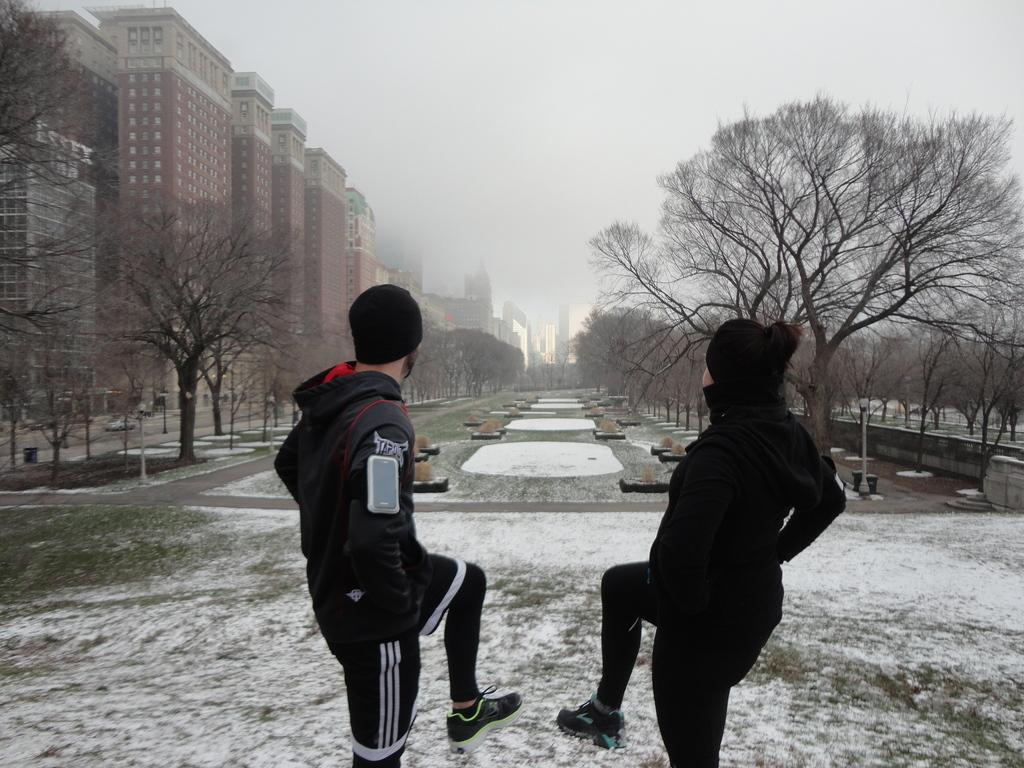What type of structures can be seen in the image? There are buildings in the image. What feature is visible on the buildings? There are windows visible in the image. What type of vegetation is present in the image? There are trees in the image. What weather condition is depicted in the image? There is snow in the image. What objects are present in the image that are used for support or guidance? There are poles in the image. What is visible at the top of the image? The sky is visible in the image. How many people are present in the image? Two people are standing in the image. Can you see a tramp being used by the people in the image? There is no tramp present in the image. Are the people in the image wearing skates? There is no indication of skates being worn by the people in the image. 